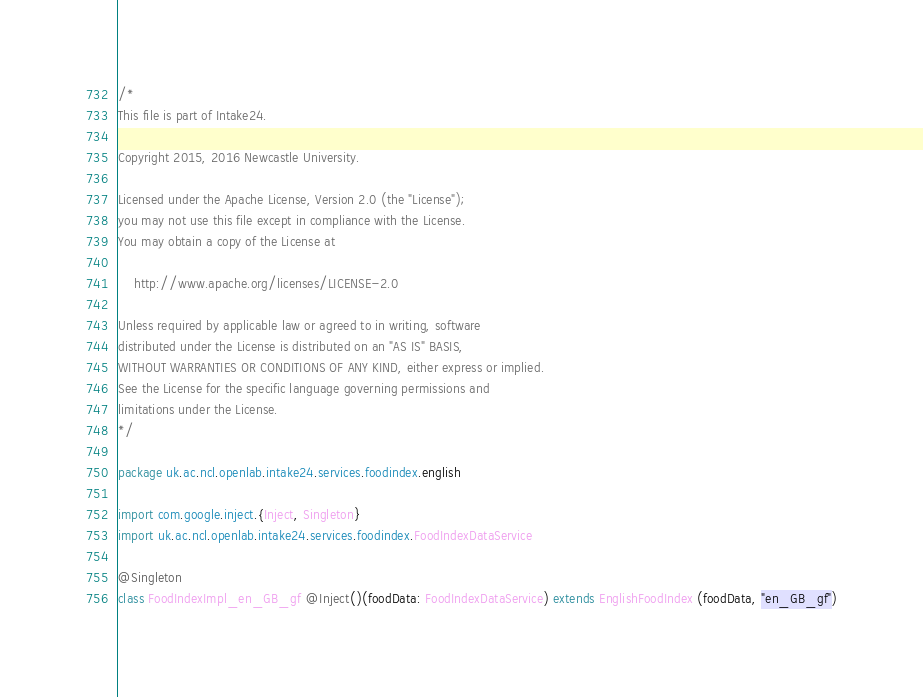<code> <loc_0><loc_0><loc_500><loc_500><_Scala_>/*
This file is part of Intake24.

Copyright 2015, 2016 Newcastle University.

Licensed under the Apache License, Version 2.0 (the "License");
you may not use this file except in compliance with the License.
You may obtain a copy of the License at

    http://www.apache.org/licenses/LICENSE-2.0

Unless required by applicable law or agreed to in writing, software
distributed under the License is distributed on an "AS IS" BASIS,
WITHOUT WARRANTIES OR CONDITIONS OF ANY KIND, either express or implied.
See the License for the specific language governing permissions and
limitations under the License.
*/

package uk.ac.ncl.openlab.intake24.services.foodindex.english

import com.google.inject.{Inject, Singleton}
import uk.ac.ncl.openlab.intake24.services.foodindex.FoodIndexDataService

@Singleton
class FoodIndexImpl_en_GB_gf @Inject()(foodData: FoodIndexDataService) extends EnglishFoodIndex (foodData, "en_GB_gf")
</code> 